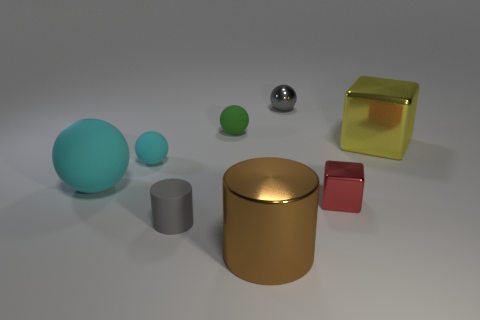What is the color of the big rubber sphere? The color of the largest rubber sphere in the image is cyan. It stands out due to its size and vibrant hue, in contrast with the relatively muted colors of the other objects surrounding it. 